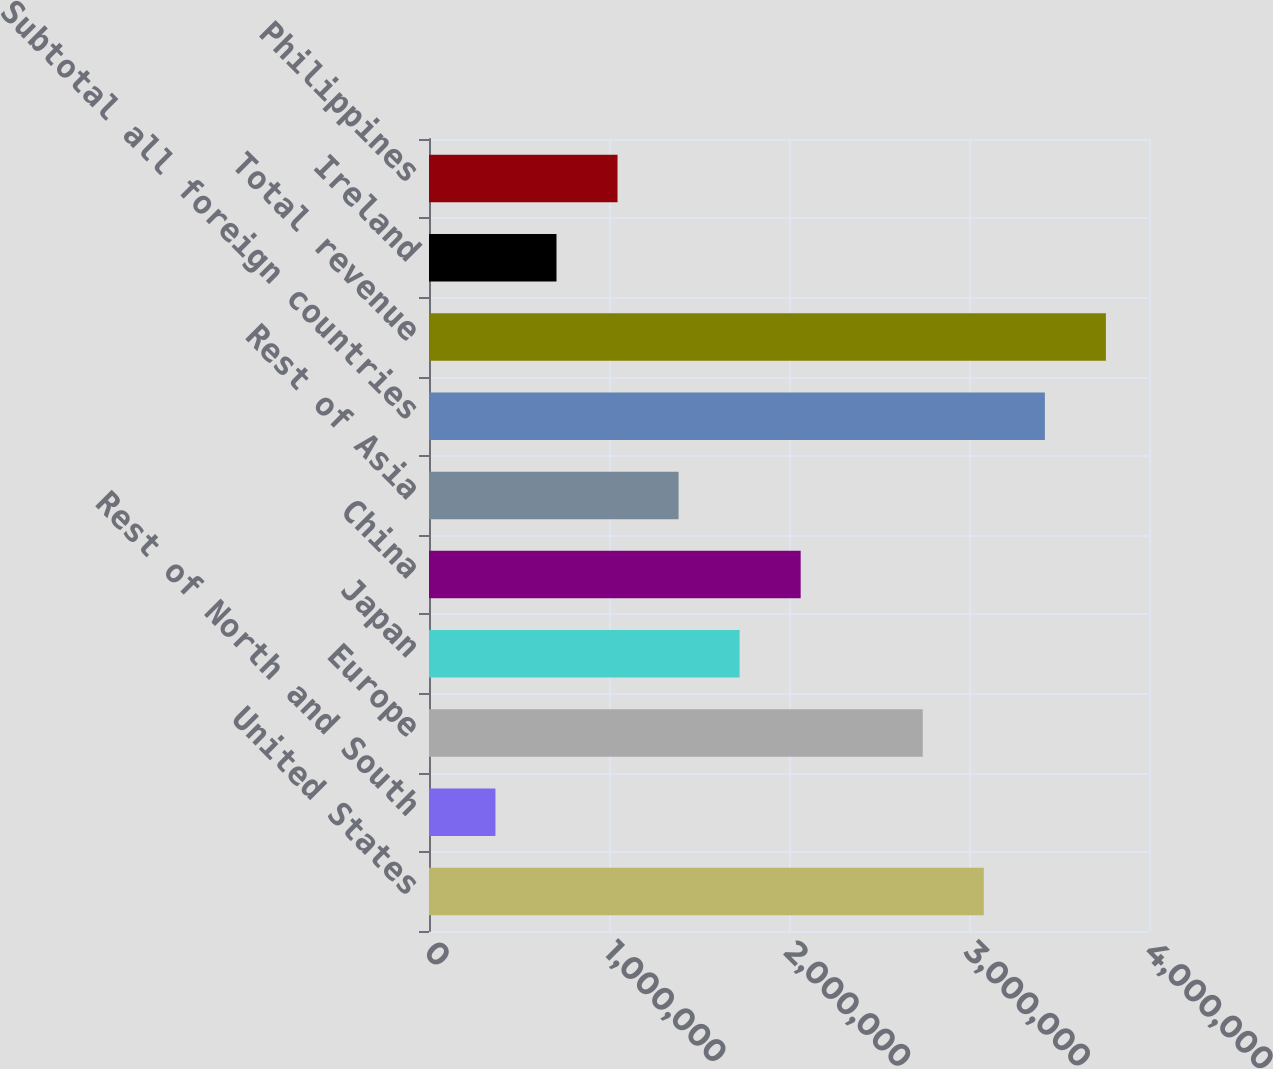<chart> <loc_0><loc_0><loc_500><loc_500><bar_chart><fcel>United States<fcel>Rest of North and South<fcel>Europe<fcel>Japan<fcel>China<fcel>Rest of Asia<fcel>Subtotal all foreign countries<fcel>Total revenue<fcel>Ireland<fcel>Philippines<nl><fcel>3.08226e+06<fcel>369098<fcel>2.74312e+06<fcel>1.72568e+06<fcel>2.06483e+06<fcel>1.38653e+06<fcel>3.42141e+06<fcel>3.76055e+06<fcel>708243<fcel>1.04739e+06<nl></chart> 